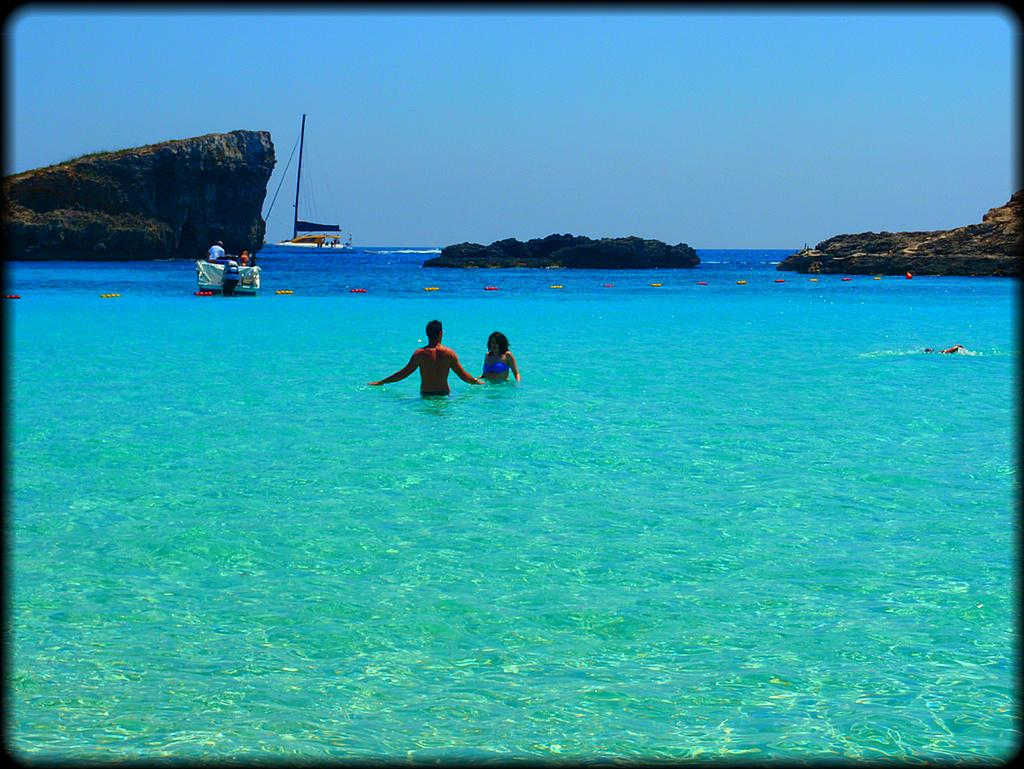What are the people in the image doing? There are people swimming in the water in the image. What else can be seen in the water besides the swimmers? There are two boats in the water, and people are in one of the boats. What can be seen in the background of the image? There is a mountain, an island with trees, and the sky visible in the background. What time of day is it in the image, and how can we tell? The time of day cannot be determined from the image, as there are no specific clues or indicators of morning or any other time of day. 